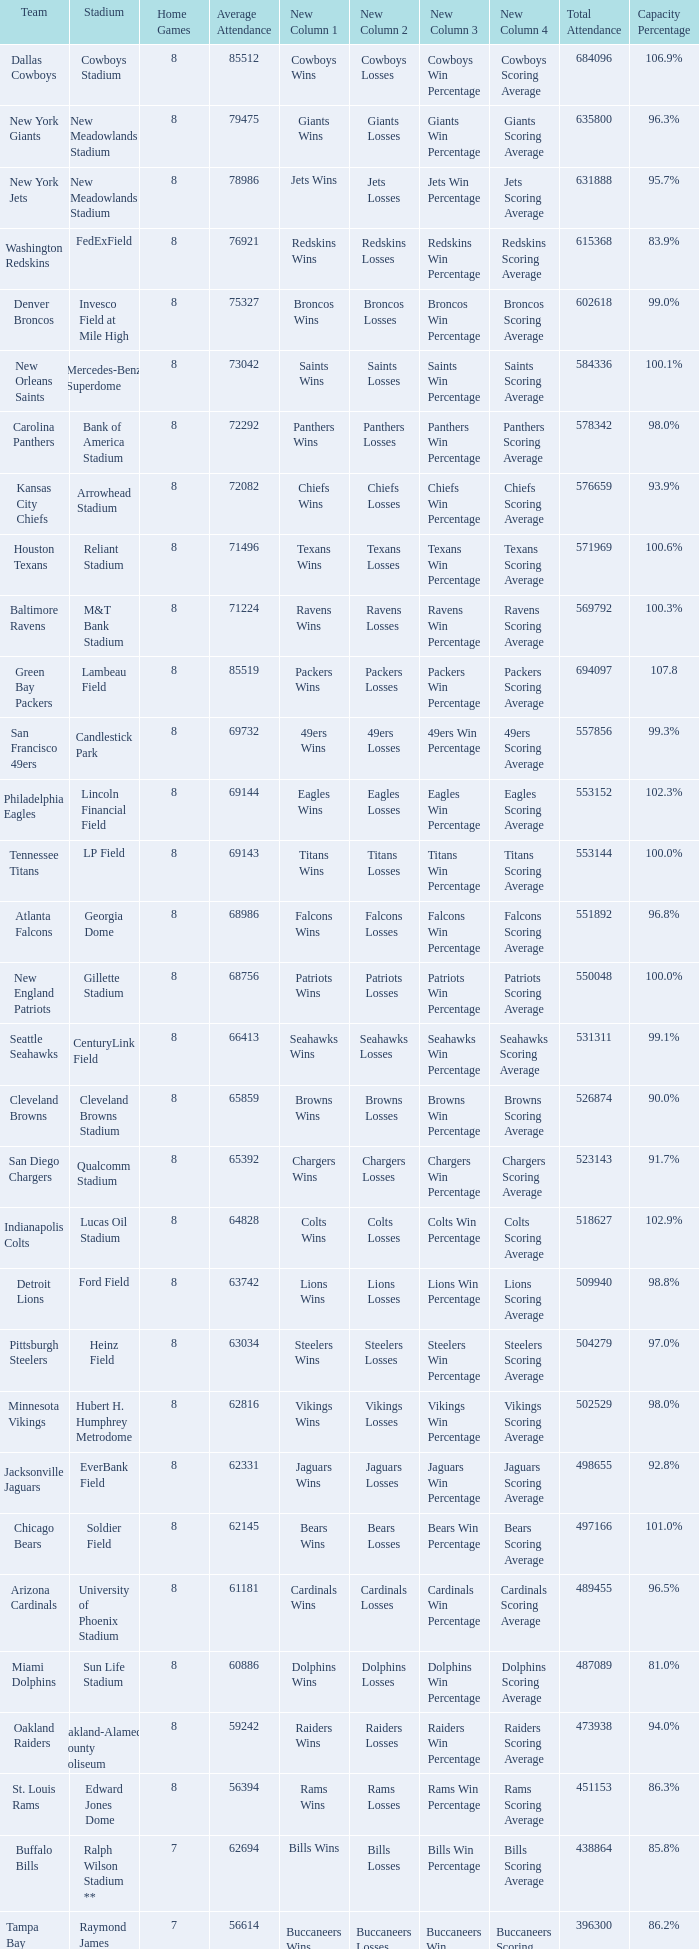Would you mind parsing the complete table? {'header': ['Team', 'Stadium', 'Home Games', 'Average Attendance', 'New Column 1', 'New Column 2', 'New Column 3', 'New Column 4', 'Total Attendance', 'Capacity Percentage'], 'rows': [['Dallas Cowboys', 'Cowboys Stadium', '8', '85512', 'Cowboys Wins', 'Cowboys Losses', 'Cowboys Win Percentage', 'Cowboys Scoring Average', '684096', '106.9%'], ['New York Giants', 'New Meadowlands Stadium', '8', '79475', 'Giants Wins', 'Giants Losses', 'Giants Win Percentage', 'Giants Scoring Average', '635800', '96.3%'], ['New York Jets', 'New Meadowlands Stadium', '8', '78986', 'Jets Wins', 'Jets Losses', 'Jets Win Percentage', 'Jets Scoring Average', '631888', '95.7%'], ['Washington Redskins', 'FedExField', '8', '76921', 'Redskins Wins', 'Redskins Losses', 'Redskins Win Percentage', 'Redskins Scoring Average', '615368', '83.9%'], ['Denver Broncos', 'Invesco Field at Mile High', '8', '75327', 'Broncos Wins', 'Broncos Losses', 'Broncos Win Percentage', 'Broncos Scoring Average', '602618', '99.0%'], ['New Orleans Saints', 'Mercedes-Benz Superdome', '8', '73042', 'Saints Wins', 'Saints Losses', 'Saints Win Percentage', 'Saints Scoring Average', '584336', '100.1%'], ['Carolina Panthers', 'Bank of America Stadium', '8', '72292', 'Panthers Wins', 'Panthers Losses', 'Panthers Win Percentage', 'Panthers Scoring Average', '578342', '98.0%'], ['Kansas City Chiefs', 'Arrowhead Stadium', '8', '72082', 'Chiefs Wins', 'Chiefs Losses', 'Chiefs Win Percentage', 'Chiefs Scoring Average', '576659', '93.9%'], ['Houston Texans', 'Reliant Stadium', '8', '71496', 'Texans Wins', 'Texans Losses', 'Texans Win Percentage', 'Texans Scoring Average', '571969', '100.6%'], ['Baltimore Ravens', 'M&T Bank Stadium', '8', '71224', 'Ravens Wins', 'Ravens Losses', 'Ravens Win Percentage', 'Ravens Scoring Average', '569792', '100.3%'], ['Green Bay Packers', 'Lambeau Field', '8', '85519', 'Packers Wins', 'Packers Losses', 'Packers Win Percentage', 'Packers Scoring Average', '694097', '107.8'], ['San Francisco 49ers', 'Candlestick Park', '8', '69732', '49ers Wins', '49ers Losses', '49ers Win Percentage', '49ers Scoring Average', '557856', '99.3%'], ['Philadelphia Eagles', 'Lincoln Financial Field', '8', '69144', 'Eagles Wins', 'Eagles Losses', 'Eagles Win Percentage', 'Eagles Scoring Average', '553152', '102.3%'], ['Tennessee Titans', 'LP Field', '8', '69143', 'Titans Wins', 'Titans Losses', 'Titans Win Percentage', 'Titans Scoring Average', '553144', '100.0%'], ['Atlanta Falcons', 'Georgia Dome', '8', '68986', 'Falcons Wins', 'Falcons Losses', 'Falcons Win Percentage', 'Falcons Scoring Average', '551892', '96.8%'], ['New England Patriots', 'Gillette Stadium', '8', '68756', 'Patriots Wins', 'Patriots Losses', 'Patriots Win Percentage', 'Patriots Scoring Average', '550048', '100.0%'], ['Seattle Seahawks', 'CenturyLink Field', '8', '66413', 'Seahawks Wins', 'Seahawks Losses', 'Seahawks Win Percentage', 'Seahawks Scoring Average', '531311', '99.1%'], ['Cleveland Browns', 'Cleveland Browns Stadium', '8', '65859', 'Browns Wins', 'Browns Losses', 'Browns Win Percentage', 'Browns Scoring Average', '526874', '90.0%'], ['San Diego Chargers', 'Qualcomm Stadium', '8', '65392', 'Chargers Wins', 'Chargers Losses', 'Chargers Win Percentage', 'Chargers Scoring Average', '523143', '91.7%'], ['Indianapolis Colts', 'Lucas Oil Stadium', '8', '64828', 'Colts Wins', 'Colts Losses', 'Colts Win Percentage', 'Colts Scoring Average', '518627', '102.9%'], ['Detroit Lions', 'Ford Field', '8', '63742', 'Lions Wins', 'Lions Losses', 'Lions Win Percentage', 'Lions Scoring Average', '509940', '98.8%'], ['Pittsburgh Steelers', 'Heinz Field', '8', '63034', 'Steelers Wins', 'Steelers Losses', 'Steelers Win Percentage', 'Steelers Scoring Average', '504279', '97.0%'], ['Minnesota Vikings', 'Hubert H. Humphrey Metrodome', '8', '62816', 'Vikings Wins', 'Vikings Losses', 'Vikings Win Percentage', 'Vikings Scoring Average', '502529', '98.0%'], ['Jacksonville Jaguars', 'EverBank Field', '8', '62331', 'Jaguars Wins', 'Jaguars Losses', 'Jaguars Win Percentage', 'Jaguars Scoring Average', '498655', '92.8%'], ['Chicago Bears', 'Soldier Field', '8', '62145', 'Bears Wins', 'Bears Losses', 'Bears Win Percentage', 'Bears Scoring Average', '497166', '101.0%'], ['Arizona Cardinals', 'University of Phoenix Stadium', '8', '61181', 'Cardinals Wins', 'Cardinals Losses', 'Cardinals Win Percentage', 'Cardinals Scoring Average', '489455', '96.5%'], ['Miami Dolphins', 'Sun Life Stadium', '8', '60886', 'Dolphins Wins', 'Dolphins Losses', 'Dolphins Win Percentage', 'Dolphins Scoring Average', '487089', '81.0%'], ['Oakland Raiders', 'Oakland-Alameda County Coliseum', '8', '59242', 'Raiders Wins', 'Raiders Losses', 'Raiders Win Percentage', 'Raiders Scoring Average', '473938', '94.0%'], ['St. Louis Rams', 'Edward Jones Dome', '8', '56394', 'Rams Wins', 'Rams Losses', 'Rams Win Percentage', 'Rams Scoring Average', '451153', '86.3%'], ['Buffalo Bills', 'Ralph Wilson Stadium **', '7', '62694', 'Bills Wins', 'Bills Losses', 'Bills Win Percentage', 'Bills Scoring Average', '438864', '85.8%'], ['Tampa Bay Buccaneers', 'Raymond James Stadium *', '7', '56614', 'Buccaneers Wins', 'Buccaneers Losses', 'Buccaneers Win Percentage', 'Buccaneers Scoring Average', '396300', '86.2%']]} How many home games are listed when the average attendance is 79475? 1.0. 